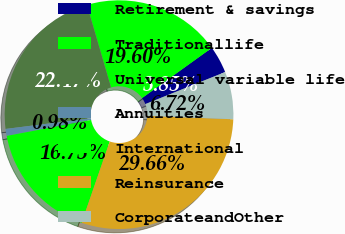<chart> <loc_0><loc_0><loc_500><loc_500><pie_chart><fcel>Retirement & savings<fcel>Traditionallife<fcel>Universal variable life<fcel>Annuities<fcel>International<fcel>Reinsurance<fcel>CorporateandOther<nl><fcel>3.85%<fcel>19.6%<fcel>22.47%<fcel>0.98%<fcel>16.73%<fcel>29.66%<fcel>6.72%<nl></chart> 